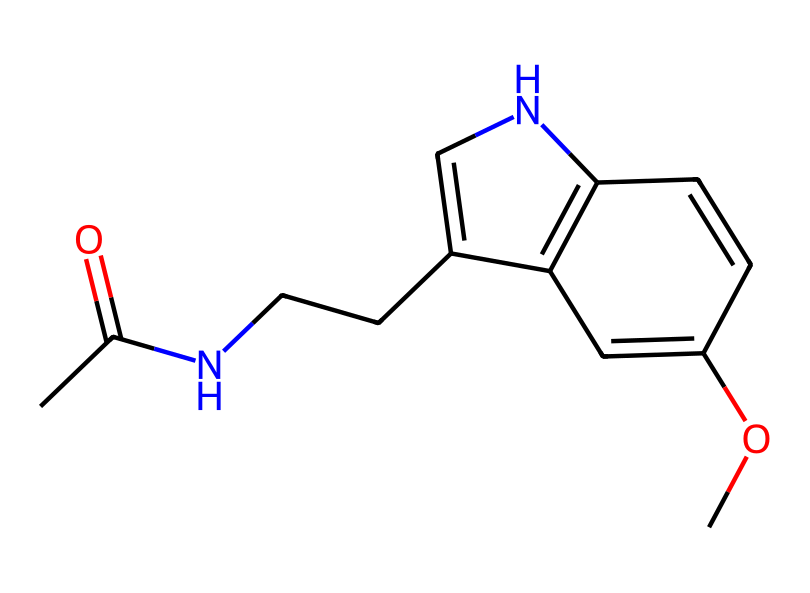what is the main functional group present in melatonin? The SMILES representation shows CC(=O), indicating a carbonyl group (C=O) with a carbon atom bonded to an -OH group, which is characteristic of acetamides. Thus, the main functional group present is the amide functional group.
Answer: amide how many carbon atoms are in melatonin? By analyzing the SMILES structure, we can count the carbon atoms: there are a total of 11 carbon atoms represented in the structure.
Answer: 11 what type of biochemical is melatonin classified as? Given that melatonin is primarily known as a hormone that regulates sleep, it falls under the category of biochemicals called 'indoles,' which contain a bicyclic structure as observed through the rings in the chemical.
Answer: indole how many rings are present in the melatonin structure? The SMILES representation displays a bicyclic structure (C1=CNc2c1), indicating that melatonin consists of two interconnected rings.
Answer: 2 what is the indicative mechanism of melatonin affecting sleep? Melatonin regulates sleep by binding to specific receptors in the brain that signal the body to prepare for sleep due to its structural compatibility, which relates directly to its cyclic nature and polar groups influencing receptor interactions.
Answer: receptor binding which element is present in the highest quantity in melatonin? From the SMILES notation, we tally the atoms: there are 11 carbon, 13 hydrogen, 2 nitrogen, and 1 oxygen, indicating that hydrogen is the most abundant element in the compound.
Answer: hydrogen 